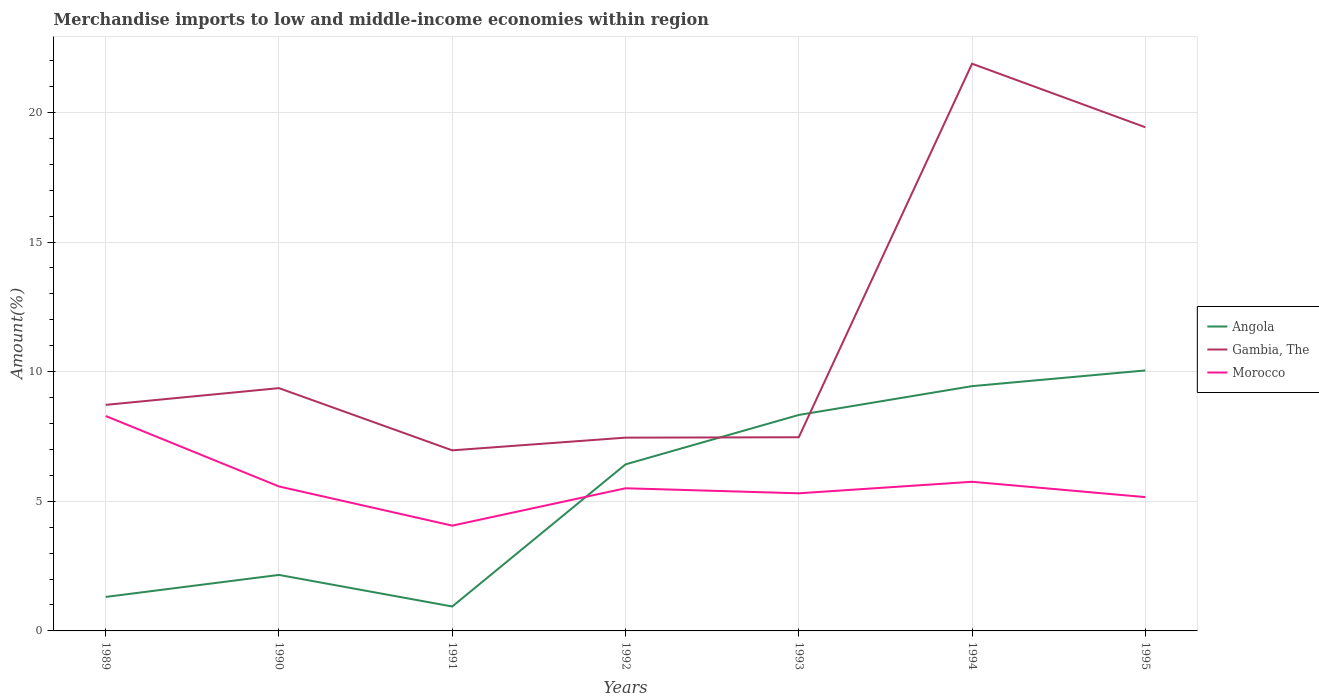Across all years, what is the maximum percentage of amount earned from merchandise imports in Gambia, The?
Your response must be concise. 6.97. In which year was the percentage of amount earned from merchandise imports in Gambia, The maximum?
Your response must be concise. 1991. What is the total percentage of amount earned from merchandise imports in Gambia, The in the graph?
Your answer should be compact. -0.65. What is the difference between the highest and the second highest percentage of amount earned from merchandise imports in Angola?
Offer a very short reply. 9.11. What is the difference between two consecutive major ticks on the Y-axis?
Your response must be concise. 5. Are the values on the major ticks of Y-axis written in scientific E-notation?
Make the answer very short. No. How many legend labels are there?
Make the answer very short. 3. What is the title of the graph?
Ensure brevity in your answer.  Merchandise imports to low and middle-income economies within region. What is the label or title of the Y-axis?
Give a very brief answer. Amount(%). What is the Amount(%) in Angola in 1989?
Offer a very short reply. 1.31. What is the Amount(%) of Gambia, The in 1989?
Offer a terse response. 8.72. What is the Amount(%) of Morocco in 1989?
Offer a terse response. 8.29. What is the Amount(%) in Angola in 1990?
Offer a very short reply. 2.16. What is the Amount(%) of Gambia, The in 1990?
Ensure brevity in your answer.  9.37. What is the Amount(%) in Morocco in 1990?
Keep it short and to the point. 5.57. What is the Amount(%) in Angola in 1991?
Offer a very short reply. 0.94. What is the Amount(%) of Gambia, The in 1991?
Keep it short and to the point. 6.97. What is the Amount(%) of Morocco in 1991?
Your answer should be very brief. 4.06. What is the Amount(%) of Angola in 1992?
Offer a terse response. 6.42. What is the Amount(%) in Gambia, The in 1992?
Offer a terse response. 7.46. What is the Amount(%) in Morocco in 1992?
Provide a short and direct response. 5.5. What is the Amount(%) in Angola in 1993?
Your answer should be very brief. 8.33. What is the Amount(%) in Gambia, The in 1993?
Offer a very short reply. 7.47. What is the Amount(%) in Morocco in 1993?
Provide a short and direct response. 5.31. What is the Amount(%) of Angola in 1994?
Make the answer very short. 9.44. What is the Amount(%) in Gambia, The in 1994?
Offer a very short reply. 21.88. What is the Amount(%) in Morocco in 1994?
Keep it short and to the point. 5.75. What is the Amount(%) of Angola in 1995?
Your response must be concise. 10.05. What is the Amount(%) of Gambia, The in 1995?
Provide a short and direct response. 19.43. What is the Amount(%) of Morocco in 1995?
Provide a short and direct response. 5.16. Across all years, what is the maximum Amount(%) of Angola?
Keep it short and to the point. 10.05. Across all years, what is the maximum Amount(%) of Gambia, The?
Make the answer very short. 21.88. Across all years, what is the maximum Amount(%) of Morocco?
Provide a succinct answer. 8.29. Across all years, what is the minimum Amount(%) in Angola?
Provide a short and direct response. 0.94. Across all years, what is the minimum Amount(%) of Gambia, The?
Make the answer very short. 6.97. Across all years, what is the minimum Amount(%) of Morocco?
Keep it short and to the point. 4.06. What is the total Amount(%) in Angola in the graph?
Keep it short and to the point. 38.66. What is the total Amount(%) in Gambia, The in the graph?
Provide a short and direct response. 81.28. What is the total Amount(%) of Morocco in the graph?
Make the answer very short. 39.65. What is the difference between the Amount(%) in Angola in 1989 and that in 1990?
Keep it short and to the point. -0.85. What is the difference between the Amount(%) of Gambia, The in 1989 and that in 1990?
Provide a short and direct response. -0.65. What is the difference between the Amount(%) in Morocco in 1989 and that in 1990?
Offer a terse response. 2.72. What is the difference between the Amount(%) of Angola in 1989 and that in 1991?
Offer a very short reply. 0.37. What is the difference between the Amount(%) of Gambia, The in 1989 and that in 1991?
Offer a very short reply. 1.75. What is the difference between the Amount(%) of Morocco in 1989 and that in 1991?
Your answer should be very brief. 4.23. What is the difference between the Amount(%) in Angola in 1989 and that in 1992?
Provide a succinct answer. -5.11. What is the difference between the Amount(%) in Gambia, The in 1989 and that in 1992?
Provide a short and direct response. 1.26. What is the difference between the Amount(%) of Morocco in 1989 and that in 1992?
Keep it short and to the point. 2.79. What is the difference between the Amount(%) of Angola in 1989 and that in 1993?
Ensure brevity in your answer.  -7.02. What is the difference between the Amount(%) of Gambia, The in 1989 and that in 1993?
Offer a terse response. 1.25. What is the difference between the Amount(%) of Morocco in 1989 and that in 1993?
Keep it short and to the point. 2.98. What is the difference between the Amount(%) in Angola in 1989 and that in 1994?
Your response must be concise. -8.13. What is the difference between the Amount(%) of Gambia, The in 1989 and that in 1994?
Your answer should be compact. -13.16. What is the difference between the Amount(%) of Morocco in 1989 and that in 1994?
Ensure brevity in your answer.  2.54. What is the difference between the Amount(%) of Angola in 1989 and that in 1995?
Provide a short and direct response. -8.74. What is the difference between the Amount(%) in Gambia, The in 1989 and that in 1995?
Your answer should be compact. -10.71. What is the difference between the Amount(%) in Morocco in 1989 and that in 1995?
Give a very brief answer. 3.13. What is the difference between the Amount(%) of Angola in 1990 and that in 1991?
Give a very brief answer. 1.22. What is the difference between the Amount(%) in Gambia, The in 1990 and that in 1991?
Make the answer very short. 2.4. What is the difference between the Amount(%) of Morocco in 1990 and that in 1991?
Your answer should be compact. 1.51. What is the difference between the Amount(%) of Angola in 1990 and that in 1992?
Make the answer very short. -4.26. What is the difference between the Amount(%) in Gambia, The in 1990 and that in 1992?
Your answer should be very brief. 1.91. What is the difference between the Amount(%) of Morocco in 1990 and that in 1992?
Provide a short and direct response. 0.07. What is the difference between the Amount(%) of Angola in 1990 and that in 1993?
Provide a short and direct response. -6.17. What is the difference between the Amount(%) of Gambia, The in 1990 and that in 1993?
Your answer should be compact. 1.89. What is the difference between the Amount(%) in Morocco in 1990 and that in 1993?
Your answer should be compact. 0.26. What is the difference between the Amount(%) in Angola in 1990 and that in 1994?
Make the answer very short. -7.28. What is the difference between the Amount(%) in Gambia, The in 1990 and that in 1994?
Offer a terse response. -12.51. What is the difference between the Amount(%) of Morocco in 1990 and that in 1994?
Offer a terse response. -0.18. What is the difference between the Amount(%) in Angola in 1990 and that in 1995?
Keep it short and to the point. -7.89. What is the difference between the Amount(%) in Gambia, The in 1990 and that in 1995?
Ensure brevity in your answer.  -10.06. What is the difference between the Amount(%) of Morocco in 1990 and that in 1995?
Offer a terse response. 0.41. What is the difference between the Amount(%) in Angola in 1991 and that in 1992?
Offer a very short reply. -5.48. What is the difference between the Amount(%) in Gambia, The in 1991 and that in 1992?
Offer a terse response. -0.49. What is the difference between the Amount(%) in Morocco in 1991 and that in 1992?
Your answer should be compact. -1.44. What is the difference between the Amount(%) of Angola in 1991 and that in 1993?
Offer a terse response. -7.39. What is the difference between the Amount(%) of Gambia, The in 1991 and that in 1993?
Offer a very short reply. -0.51. What is the difference between the Amount(%) in Morocco in 1991 and that in 1993?
Provide a succinct answer. -1.25. What is the difference between the Amount(%) in Angola in 1991 and that in 1994?
Provide a short and direct response. -8.5. What is the difference between the Amount(%) of Gambia, The in 1991 and that in 1994?
Offer a terse response. -14.91. What is the difference between the Amount(%) in Morocco in 1991 and that in 1994?
Provide a succinct answer. -1.69. What is the difference between the Amount(%) of Angola in 1991 and that in 1995?
Ensure brevity in your answer.  -9.11. What is the difference between the Amount(%) of Gambia, The in 1991 and that in 1995?
Your answer should be compact. -12.46. What is the difference between the Amount(%) of Morocco in 1991 and that in 1995?
Your answer should be compact. -1.1. What is the difference between the Amount(%) in Angola in 1992 and that in 1993?
Your answer should be compact. -1.91. What is the difference between the Amount(%) in Gambia, The in 1992 and that in 1993?
Offer a very short reply. -0.01. What is the difference between the Amount(%) in Morocco in 1992 and that in 1993?
Ensure brevity in your answer.  0.19. What is the difference between the Amount(%) in Angola in 1992 and that in 1994?
Offer a very short reply. -3.02. What is the difference between the Amount(%) in Gambia, The in 1992 and that in 1994?
Your response must be concise. -14.42. What is the difference between the Amount(%) in Morocco in 1992 and that in 1994?
Your response must be concise. -0.25. What is the difference between the Amount(%) in Angola in 1992 and that in 1995?
Your response must be concise. -3.62. What is the difference between the Amount(%) of Gambia, The in 1992 and that in 1995?
Provide a short and direct response. -11.97. What is the difference between the Amount(%) of Morocco in 1992 and that in 1995?
Give a very brief answer. 0.34. What is the difference between the Amount(%) of Angola in 1993 and that in 1994?
Give a very brief answer. -1.11. What is the difference between the Amount(%) in Gambia, The in 1993 and that in 1994?
Your response must be concise. -14.41. What is the difference between the Amount(%) in Morocco in 1993 and that in 1994?
Your answer should be very brief. -0.44. What is the difference between the Amount(%) of Angola in 1993 and that in 1995?
Your answer should be compact. -1.72. What is the difference between the Amount(%) in Gambia, The in 1993 and that in 1995?
Provide a succinct answer. -11.96. What is the difference between the Amount(%) in Morocco in 1993 and that in 1995?
Provide a succinct answer. 0.15. What is the difference between the Amount(%) of Angola in 1994 and that in 1995?
Provide a succinct answer. -0.61. What is the difference between the Amount(%) of Gambia, The in 1994 and that in 1995?
Provide a succinct answer. 2.45. What is the difference between the Amount(%) in Morocco in 1994 and that in 1995?
Your answer should be very brief. 0.59. What is the difference between the Amount(%) in Angola in 1989 and the Amount(%) in Gambia, The in 1990?
Keep it short and to the point. -8.05. What is the difference between the Amount(%) in Angola in 1989 and the Amount(%) in Morocco in 1990?
Make the answer very short. -4.26. What is the difference between the Amount(%) in Gambia, The in 1989 and the Amount(%) in Morocco in 1990?
Your answer should be very brief. 3.15. What is the difference between the Amount(%) of Angola in 1989 and the Amount(%) of Gambia, The in 1991?
Give a very brief answer. -5.65. What is the difference between the Amount(%) in Angola in 1989 and the Amount(%) in Morocco in 1991?
Make the answer very short. -2.75. What is the difference between the Amount(%) in Gambia, The in 1989 and the Amount(%) in Morocco in 1991?
Make the answer very short. 4.66. What is the difference between the Amount(%) of Angola in 1989 and the Amount(%) of Gambia, The in 1992?
Give a very brief answer. -6.14. What is the difference between the Amount(%) of Angola in 1989 and the Amount(%) of Morocco in 1992?
Make the answer very short. -4.19. What is the difference between the Amount(%) in Gambia, The in 1989 and the Amount(%) in Morocco in 1992?
Provide a succinct answer. 3.22. What is the difference between the Amount(%) in Angola in 1989 and the Amount(%) in Gambia, The in 1993?
Offer a terse response. -6.16. What is the difference between the Amount(%) of Angola in 1989 and the Amount(%) of Morocco in 1993?
Your answer should be compact. -4. What is the difference between the Amount(%) of Gambia, The in 1989 and the Amount(%) of Morocco in 1993?
Provide a succinct answer. 3.41. What is the difference between the Amount(%) of Angola in 1989 and the Amount(%) of Gambia, The in 1994?
Offer a terse response. -20.57. What is the difference between the Amount(%) of Angola in 1989 and the Amount(%) of Morocco in 1994?
Offer a terse response. -4.44. What is the difference between the Amount(%) in Gambia, The in 1989 and the Amount(%) in Morocco in 1994?
Keep it short and to the point. 2.97. What is the difference between the Amount(%) in Angola in 1989 and the Amount(%) in Gambia, The in 1995?
Offer a very short reply. -18.12. What is the difference between the Amount(%) of Angola in 1989 and the Amount(%) of Morocco in 1995?
Keep it short and to the point. -3.85. What is the difference between the Amount(%) of Gambia, The in 1989 and the Amount(%) of Morocco in 1995?
Provide a succinct answer. 3.56. What is the difference between the Amount(%) in Angola in 1990 and the Amount(%) in Gambia, The in 1991?
Keep it short and to the point. -4.81. What is the difference between the Amount(%) of Angola in 1990 and the Amount(%) of Morocco in 1991?
Your response must be concise. -1.9. What is the difference between the Amount(%) in Gambia, The in 1990 and the Amount(%) in Morocco in 1991?
Ensure brevity in your answer.  5.3. What is the difference between the Amount(%) in Angola in 1990 and the Amount(%) in Gambia, The in 1992?
Your answer should be compact. -5.3. What is the difference between the Amount(%) in Angola in 1990 and the Amount(%) in Morocco in 1992?
Offer a terse response. -3.34. What is the difference between the Amount(%) of Gambia, The in 1990 and the Amount(%) of Morocco in 1992?
Ensure brevity in your answer.  3.86. What is the difference between the Amount(%) in Angola in 1990 and the Amount(%) in Gambia, The in 1993?
Provide a short and direct response. -5.31. What is the difference between the Amount(%) of Angola in 1990 and the Amount(%) of Morocco in 1993?
Keep it short and to the point. -3.15. What is the difference between the Amount(%) of Gambia, The in 1990 and the Amount(%) of Morocco in 1993?
Give a very brief answer. 4.06. What is the difference between the Amount(%) of Angola in 1990 and the Amount(%) of Gambia, The in 1994?
Make the answer very short. -19.72. What is the difference between the Amount(%) in Angola in 1990 and the Amount(%) in Morocco in 1994?
Your answer should be very brief. -3.59. What is the difference between the Amount(%) of Gambia, The in 1990 and the Amount(%) of Morocco in 1994?
Make the answer very short. 3.61. What is the difference between the Amount(%) of Angola in 1990 and the Amount(%) of Gambia, The in 1995?
Your response must be concise. -17.27. What is the difference between the Amount(%) in Angola in 1990 and the Amount(%) in Morocco in 1995?
Your answer should be very brief. -3. What is the difference between the Amount(%) of Gambia, The in 1990 and the Amount(%) of Morocco in 1995?
Provide a short and direct response. 4.2. What is the difference between the Amount(%) of Angola in 1991 and the Amount(%) of Gambia, The in 1992?
Make the answer very short. -6.51. What is the difference between the Amount(%) in Angola in 1991 and the Amount(%) in Morocco in 1992?
Make the answer very short. -4.56. What is the difference between the Amount(%) in Gambia, The in 1991 and the Amount(%) in Morocco in 1992?
Give a very brief answer. 1.46. What is the difference between the Amount(%) of Angola in 1991 and the Amount(%) of Gambia, The in 1993?
Keep it short and to the point. -6.53. What is the difference between the Amount(%) in Angola in 1991 and the Amount(%) in Morocco in 1993?
Offer a very short reply. -4.37. What is the difference between the Amount(%) of Gambia, The in 1991 and the Amount(%) of Morocco in 1993?
Make the answer very short. 1.66. What is the difference between the Amount(%) of Angola in 1991 and the Amount(%) of Gambia, The in 1994?
Offer a very short reply. -20.94. What is the difference between the Amount(%) in Angola in 1991 and the Amount(%) in Morocco in 1994?
Keep it short and to the point. -4.81. What is the difference between the Amount(%) in Gambia, The in 1991 and the Amount(%) in Morocco in 1994?
Make the answer very short. 1.21. What is the difference between the Amount(%) of Angola in 1991 and the Amount(%) of Gambia, The in 1995?
Your answer should be compact. -18.49. What is the difference between the Amount(%) in Angola in 1991 and the Amount(%) in Morocco in 1995?
Your answer should be very brief. -4.22. What is the difference between the Amount(%) in Gambia, The in 1991 and the Amount(%) in Morocco in 1995?
Your answer should be very brief. 1.8. What is the difference between the Amount(%) of Angola in 1992 and the Amount(%) of Gambia, The in 1993?
Your response must be concise. -1.05. What is the difference between the Amount(%) of Angola in 1992 and the Amount(%) of Morocco in 1993?
Your answer should be very brief. 1.12. What is the difference between the Amount(%) in Gambia, The in 1992 and the Amount(%) in Morocco in 1993?
Offer a very short reply. 2.15. What is the difference between the Amount(%) of Angola in 1992 and the Amount(%) of Gambia, The in 1994?
Keep it short and to the point. -15.45. What is the difference between the Amount(%) of Angola in 1992 and the Amount(%) of Morocco in 1994?
Your answer should be very brief. 0.67. What is the difference between the Amount(%) of Gambia, The in 1992 and the Amount(%) of Morocco in 1994?
Your answer should be compact. 1.7. What is the difference between the Amount(%) of Angola in 1992 and the Amount(%) of Gambia, The in 1995?
Ensure brevity in your answer.  -13. What is the difference between the Amount(%) in Angola in 1992 and the Amount(%) in Morocco in 1995?
Your answer should be very brief. 1.26. What is the difference between the Amount(%) of Gambia, The in 1992 and the Amount(%) of Morocco in 1995?
Make the answer very short. 2.29. What is the difference between the Amount(%) in Angola in 1993 and the Amount(%) in Gambia, The in 1994?
Your answer should be very brief. -13.55. What is the difference between the Amount(%) of Angola in 1993 and the Amount(%) of Morocco in 1994?
Offer a very short reply. 2.58. What is the difference between the Amount(%) of Gambia, The in 1993 and the Amount(%) of Morocco in 1994?
Make the answer very short. 1.72. What is the difference between the Amount(%) in Angola in 1993 and the Amount(%) in Gambia, The in 1995?
Make the answer very short. -11.1. What is the difference between the Amount(%) in Angola in 1993 and the Amount(%) in Morocco in 1995?
Make the answer very short. 3.17. What is the difference between the Amount(%) in Gambia, The in 1993 and the Amount(%) in Morocco in 1995?
Offer a terse response. 2.31. What is the difference between the Amount(%) of Angola in 1994 and the Amount(%) of Gambia, The in 1995?
Ensure brevity in your answer.  -9.99. What is the difference between the Amount(%) in Angola in 1994 and the Amount(%) in Morocco in 1995?
Provide a short and direct response. 4.28. What is the difference between the Amount(%) in Gambia, The in 1994 and the Amount(%) in Morocco in 1995?
Your answer should be compact. 16.72. What is the average Amount(%) of Angola per year?
Offer a very short reply. 5.52. What is the average Amount(%) in Gambia, The per year?
Make the answer very short. 11.61. What is the average Amount(%) of Morocco per year?
Ensure brevity in your answer.  5.66. In the year 1989, what is the difference between the Amount(%) of Angola and Amount(%) of Gambia, The?
Your response must be concise. -7.41. In the year 1989, what is the difference between the Amount(%) in Angola and Amount(%) in Morocco?
Your answer should be very brief. -6.98. In the year 1989, what is the difference between the Amount(%) in Gambia, The and Amount(%) in Morocco?
Provide a succinct answer. 0.43. In the year 1990, what is the difference between the Amount(%) in Angola and Amount(%) in Gambia, The?
Give a very brief answer. -7.21. In the year 1990, what is the difference between the Amount(%) of Angola and Amount(%) of Morocco?
Provide a short and direct response. -3.41. In the year 1990, what is the difference between the Amount(%) of Gambia, The and Amount(%) of Morocco?
Your answer should be compact. 3.79. In the year 1991, what is the difference between the Amount(%) of Angola and Amount(%) of Gambia, The?
Give a very brief answer. -6.02. In the year 1991, what is the difference between the Amount(%) in Angola and Amount(%) in Morocco?
Offer a very short reply. -3.12. In the year 1991, what is the difference between the Amount(%) in Gambia, The and Amount(%) in Morocco?
Provide a short and direct response. 2.9. In the year 1992, what is the difference between the Amount(%) in Angola and Amount(%) in Gambia, The?
Make the answer very short. -1.03. In the year 1992, what is the difference between the Amount(%) of Angola and Amount(%) of Morocco?
Provide a short and direct response. 0.92. In the year 1992, what is the difference between the Amount(%) of Gambia, The and Amount(%) of Morocco?
Your answer should be very brief. 1.95. In the year 1993, what is the difference between the Amount(%) in Angola and Amount(%) in Gambia, The?
Provide a succinct answer. 0.86. In the year 1993, what is the difference between the Amount(%) of Angola and Amount(%) of Morocco?
Keep it short and to the point. 3.02. In the year 1993, what is the difference between the Amount(%) in Gambia, The and Amount(%) in Morocco?
Provide a succinct answer. 2.16. In the year 1994, what is the difference between the Amount(%) in Angola and Amount(%) in Gambia, The?
Make the answer very short. -12.44. In the year 1994, what is the difference between the Amount(%) in Angola and Amount(%) in Morocco?
Offer a terse response. 3.69. In the year 1994, what is the difference between the Amount(%) in Gambia, The and Amount(%) in Morocco?
Your response must be concise. 16.13. In the year 1995, what is the difference between the Amount(%) in Angola and Amount(%) in Gambia, The?
Ensure brevity in your answer.  -9.38. In the year 1995, what is the difference between the Amount(%) in Angola and Amount(%) in Morocco?
Your answer should be very brief. 4.89. In the year 1995, what is the difference between the Amount(%) of Gambia, The and Amount(%) of Morocco?
Your answer should be compact. 14.27. What is the ratio of the Amount(%) in Angola in 1989 to that in 1990?
Offer a terse response. 0.61. What is the ratio of the Amount(%) in Gambia, The in 1989 to that in 1990?
Your response must be concise. 0.93. What is the ratio of the Amount(%) in Morocco in 1989 to that in 1990?
Your answer should be compact. 1.49. What is the ratio of the Amount(%) of Angola in 1989 to that in 1991?
Ensure brevity in your answer.  1.39. What is the ratio of the Amount(%) of Gambia, The in 1989 to that in 1991?
Offer a very short reply. 1.25. What is the ratio of the Amount(%) in Morocco in 1989 to that in 1991?
Your answer should be very brief. 2.04. What is the ratio of the Amount(%) of Angola in 1989 to that in 1992?
Offer a very short reply. 0.2. What is the ratio of the Amount(%) in Gambia, The in 1989 to that in 1992?
Offer a terse response. 1.17. What is the ratio of the Amount(%) of Morocco in 1989 to that in 1992?
Offer a terse response. 1.51. What is the ratio of the Amount(%) in Angola in 1989 to that in 1993?
Offer a terse response. 0.16. What is the ratio of the Amount(%) of Gambia, The in 1989 to that in 1993?
Your answer should be compact. 1.17. What is the ratio of the Amount(%) in Morocco in 1989 to that in 1993?
Your answer should be compact. 1.56. What is the ratio of the Amount(%) of Angola in 1989 to that in 1994?
Give a very brief answer. 0.14. What is the ratio of the Amount(%) in Gambia, The in 1989 to that in 1994?
Provide a short and direct response. 0.4. What is the ratio of the Amount(%) of Morocco in 1989 to that in 1994?
Ensure brevity in your answer.  1.44. What is the ratio of the Amount(%) in Angola in 1989 to that in 1995?
Your response must be concise. 0.13. What is the ratio of the Amount(%) in Gambia, The in 1989 to that in 1995?
Your response must be concise. 0.45. What is the ratio of the Amount(%) of Morocco in 1989 to that in 1995?
Your answer should be compact. 1.61. What is the ratio of the Amount(%) in Angola in 1990 to that in 1991?
Your response must be concise. 2.29. What is the ratio of the Amount(%) in Gambia, The in 1990 to that in 1991?
Your answer should be very brief. 1.34. What is the ratio of the Amount(%) of Morocco in 1990 to that in 1991?
Your response must be concise. 1.37. What is the ratio of the Amount(%) in Angola in 1990 to that in 1992?
Your response must be concise. 0.34. What is the ratio of the Amount(%) of Gambia, The in 1990 to that in 1992?
Provide a short and direct response. 1.26. What is the ratio of the Amount(%) in Morocco in 1990 to that in 1992?
Keep it short and to the point. 1.01. What is the ratio of the Amount(%) of Angola in 1990 to that in 1993?
Keep it short and to the point. 0.26. What is the ratio of the Amount(%) in Gambia, The in 1990 to that in 1993?
Keep it short and to the point. 1.25. What is the ratio of the Amount(%) of Morocco in 1990 to that in 1993?
Offer a terse response. 1.05. What is the ratio of the Amount(%) in Angola in 1990 to that in 1994?
Your answer should be compact. 0.23. What is the ratio of the Amount(%) of Gambia, The in 1990 to that in 1994?
Give a very brief answer. 0.43. What is the ratio of the Amount(%) in Morocco in 1990 to that in 1994?
Make the answer very short. 0.97. What is the ratio of the Amount(%) of Angola in 1990 to that in 1995?
Offer a very short reply. 0.21. What is the ratio of the Amount(%) of Gambia, The in 1990 to that in 1995?
Provide a short and direct response. 0.48. What is the ratio of the Amount(%) of Morocco in 1990 to that in 1995?
Keep it short and to the point. 1.08. What is the ratio of the Amount(%) in Angola in 1991 to that in 1992?
Your answer should be very brief. 0.15. What is the ratio of the Amount(%) in Gambia, The in 1991 to that in 1992?
Your answer should be compact. 0.93. What is the ratio of the Amount(%) in Morocco in 1991 to that in 1992?
Provide a succinct answer. 0.74. What is the ratio of the Amount(%) of Angola in 1991 to that in 1993?
Your answer should be compact. 0.11. What is the ratio of the Amount(%) in Gambia, The in 1991 to that in 1993?
Offer a very short reply. 0.93. What is the ratio of the Amount(%) in Morocco in 1991 to that in 1993?
Keep it short and to the point. 0.77. What is the ratio of the Amount(%) of Angola in 1991 to that in 1994?
Give a very brief answer. 0.1. What is the ratio of the Amount(%) of Gambia, The in 1991 to that in 1994?
Your response must be concise. 0.32. What is the ratio of the Amount(%) of Morocco in 1991 to that in 1994?
Your answer should be very brief. 0.71. What is the ratio of the Amount(%) in Angola in 1991 to that in 1995?
Ensure brevity in your answer.  0.09. What is the ratio of the Amount(%) of Gambia, The in 1991 to that in 1995?
Ensure brevity in your answer.  0.36. What is the ratio of the Amount(%) of Morocco in 1991 to that in 1995?
Keep it short and to the point. 0.79. What is the ratio of the Amount(%) in Angola in 1992 to that in 1993?
Ensure brevity in your answer.  0.77. What is the ratio of the Amount(%) in Morocco in 1992 to that in 1993?
Your response must be concise. 1.04. What is the ratio of the Amount(%) of Angola in 1992 to that in 1994?
Provide a short and direct response. 0.68. What is the ratio of the Amount(%) in Gambia, The in 1992 to that in 1994?
Give a very brief answer. 0.34. What is the ratio of the Amount(%) in Morocco in 1992 to that in 1994?
Provide a short and direct response. 0.96. What is the ratio of the Amount(%) of Angola in 1992 to that in 1995?
Offer a terse response. 0.64. What is the ratio of the Amount(%) of Gambia, The in 1992 to that in 1995?
Make the answer very short. 0.38. What is the ratio of the Amount(%) in Morocco in 1992 to that in 1995?
Provide a short and direct response. 1.07. What is the ratio of the Amount(%) of Angola in 1993 to that in 1994?
Give a very brief answer. 0.88. What is the ratio of the Amount(%) of Gambia, The in 1993 to that in 1994?
Make the answer very short. 0.34. What is the ratio of the Amount(%) of Morocco in 1993 to that in 1994?
Your answer should be very brief. 0.92. What is the ratio of the Amount(%) of Angola in 1993 to that in 1995?
Provide a short and direct response. 0.83. What is the ratio of the Amount(%) in Gambia, The in 1993 to that in 1995?
Offer a terse response. 0.38. What is the ratio of the Amount(%) in Morocco in 1993 to that in 1995?
Offer a terse response. 1.03. What is the ratio of the Amount(%) of Angola in 1994 to that in 1995?
Offer a terse response. 0.94. What is the ratio of the Amount(%) of Gambia, The in 1994 to that in 1995?
Provide a short and direct response. 1.13. What is the ratio of the Amount(%) in Morocco in 1994 to that in 1995?
Give a very brief answer. 1.11. What is the difference between the highest and the second highest Amount(%) of Angola?
Provide a succinct answer. 0.61. What is the difference between the highest and the second highest Amount(%) in Gambia, The?
Ensure brevity in your answer.  2.45. What is the difference between the highest and the second highest Amount(%) in Morocco?
Offer a terse response. 2.54. What is the difference between the highest and the lowest Amount(%) of Angola?
Your answer should be very brief. 9.11. What is the difference between the highest and the lowest Amount(%) in Gambia, The?
Ensure brevity in your answer.  14.91. What is the difference between the highest and the lowest Amount(%) of Morocco?
Offer a terse response. 4.23. 